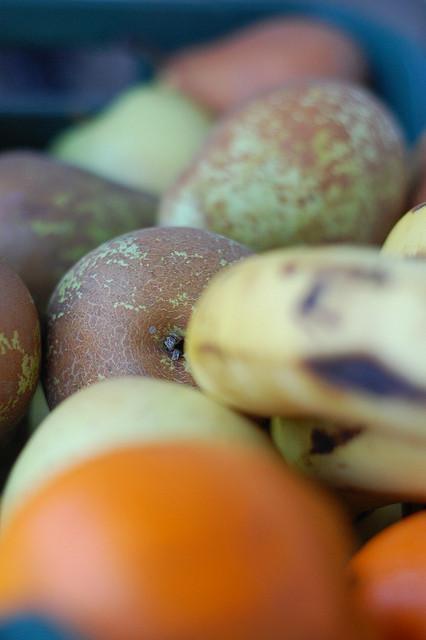Is the statement "The orange is in front of the banana." accurate regarding the image?
Answer yes or no. Yes. 